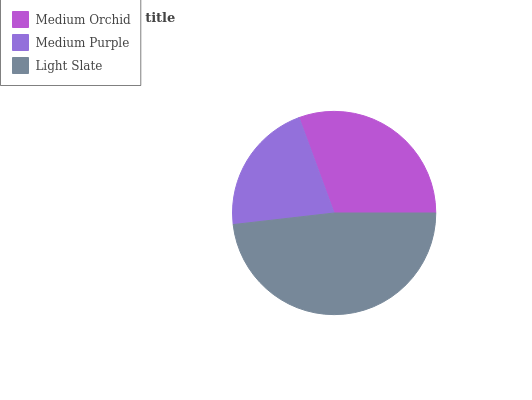Is Medium Purple the minimum?
Answer yes or no. Yes. Is Light Slate the maximum?
Answer yes or no. Yes. Is Light Slate the minimum?
Answer yes or no. No. Is Medium Purple the maximum?
Answer yes or no. No. Is Light Slate greater than Medium Purple?
Answer yes or no. Yes. Is Medium Purple less than Light Slate?
Answer yes or no. Yes. Is Medium Purple greater than Light Slate?
Answer yes or no. No. Is Light Slate less than Medium Purple?
Answer yes or no. No. Is Medium Orchid the high median?
Answer yes or no. Yes. Is Medium Orchid the low median?
Answer yes or no. Yes. Is Light Slate the high median?
Answer yes or no. No. Is Light Slate the low median?
Answer yes or no. No. 